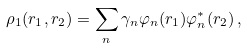<formula> <loc_0><loc_0><loc_500><loc_500>\rho _ { 1 } ( { r } _ { 1 } , { r } _ { 2 } ) = \sum _ { n } \gamma _ { n } \varphi _ { n } ( { r } _ { 1 } ) \varphi _ { n } ^ { \ast } ( { r } _ { 2 } ) \, ,</formula> 